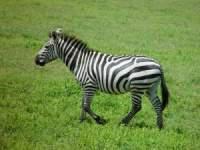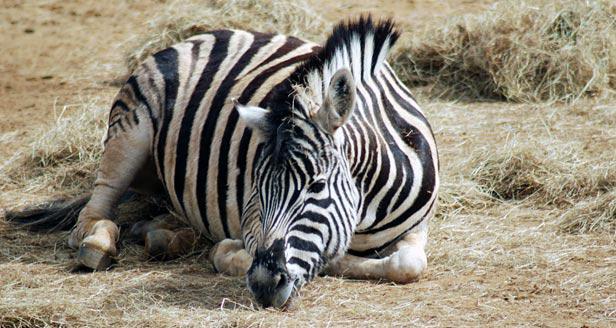The first image is the image on the left, the second image is the image on the right. Considering the images on both sides, is "The left and right image contains a total of three zebras." valid? Answer yes or no. No. The first image is the image on the left, the second image is the image on the right. Examine the images to the left and right. Is the description "The right image shows one zebra reclining on the ground with its front legs folded under its body." accurate? Answer yes or no. Yes. 